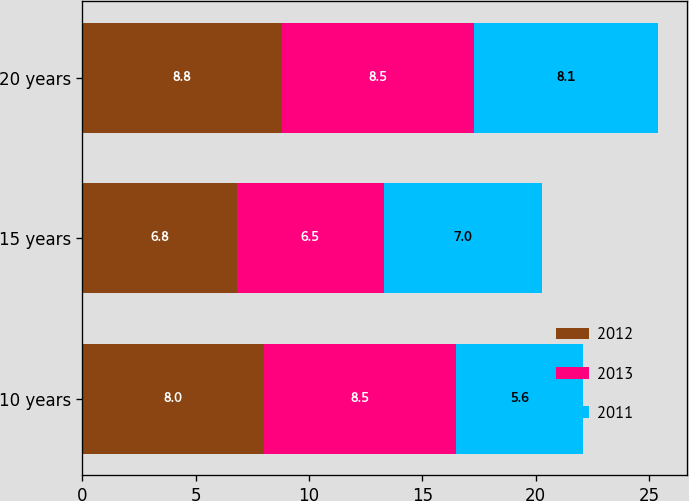Convert chart. <chart><loc_0><loc_0><loc_500><loc_500><stacked_bar_chart><ecel><fcel>10 years<fcel>15 years<fcel>20 years<nl><fcel>2012<fcel>8<fcel>6.8<fcel>8.8<nl><fcel>2013<fcel>8.5<fcel>6.5<fcel>8.5<nl><fcel>2011<fcel>5.6<fcel>7<fcel>8.1<nl></chart> 